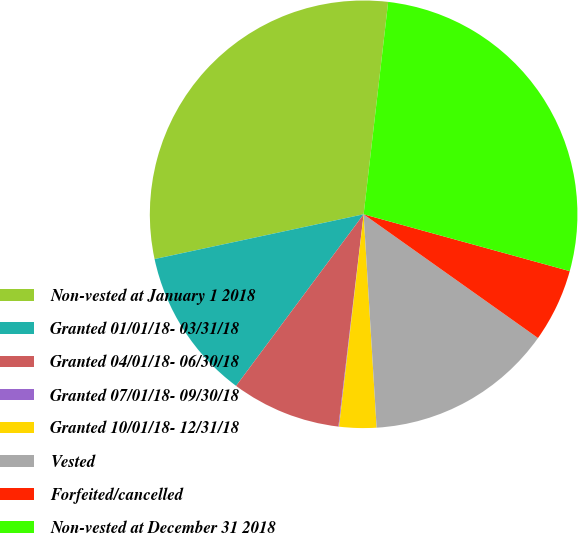Convert chart. <chart><loc_0><loc_0><loc_500><loc_500><pie_chart><fcel>Non-vested at January 1 2018<fcel>Granted 01/01/18- 03/31/18<fcel>Granted 04/01/18- 06/30/18<fcel>Granted 07/01/18- 09/30/18<fcel>Granted 10/01/18- 12/31/18<fcel>Vested<fcel>Forfeited/cancelled<fcel>Non-vested at December 31 2018<nl><fcel>30.19%<fcel>11.47%<fcel>8.29%<fcel>0.05%<fcel>2.8%<fcel>14.21%<fcel>5.54%<fcel>27.45%<nl></chart> 